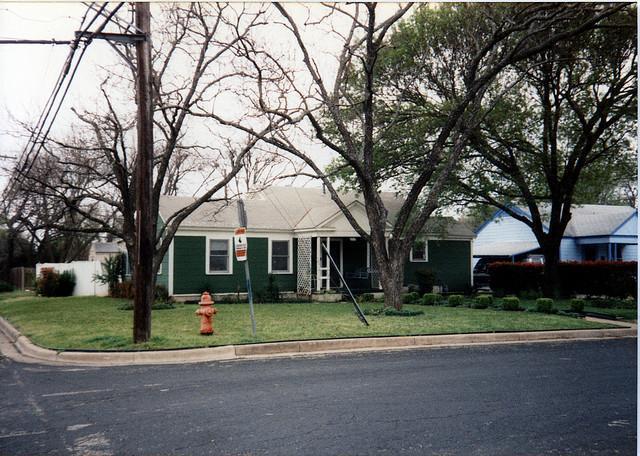How many cars are in the driveway?
Give a very brief answer. 0. 